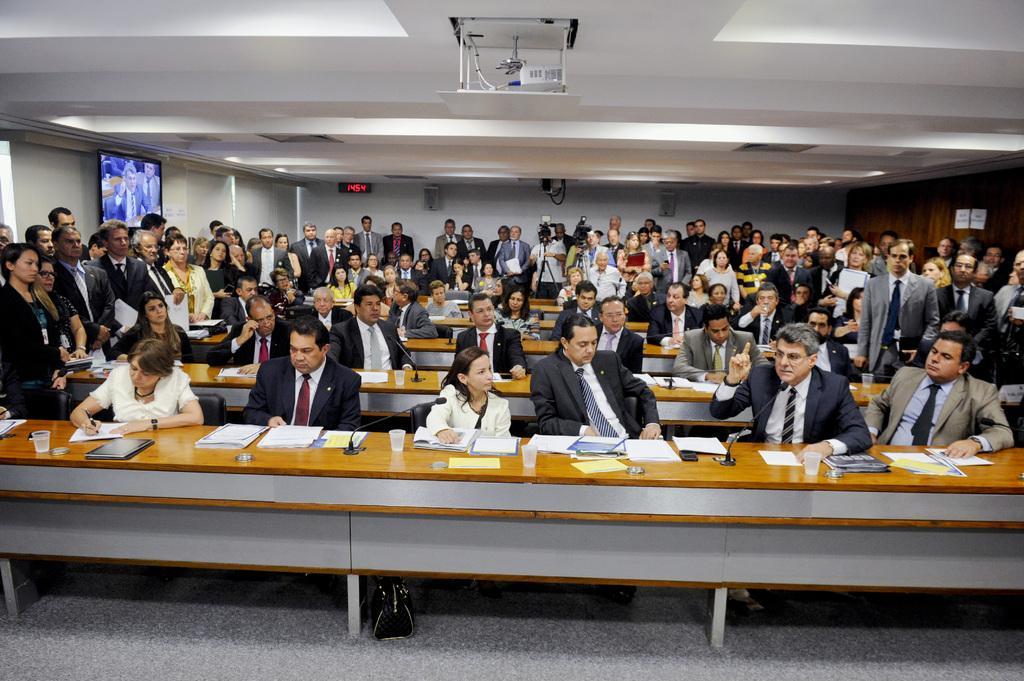In one or two sentences, can you explain what this image depicts? This picture shows some people sitting on the table and most of them are standing and backdrop there is a projector and there is a clock 